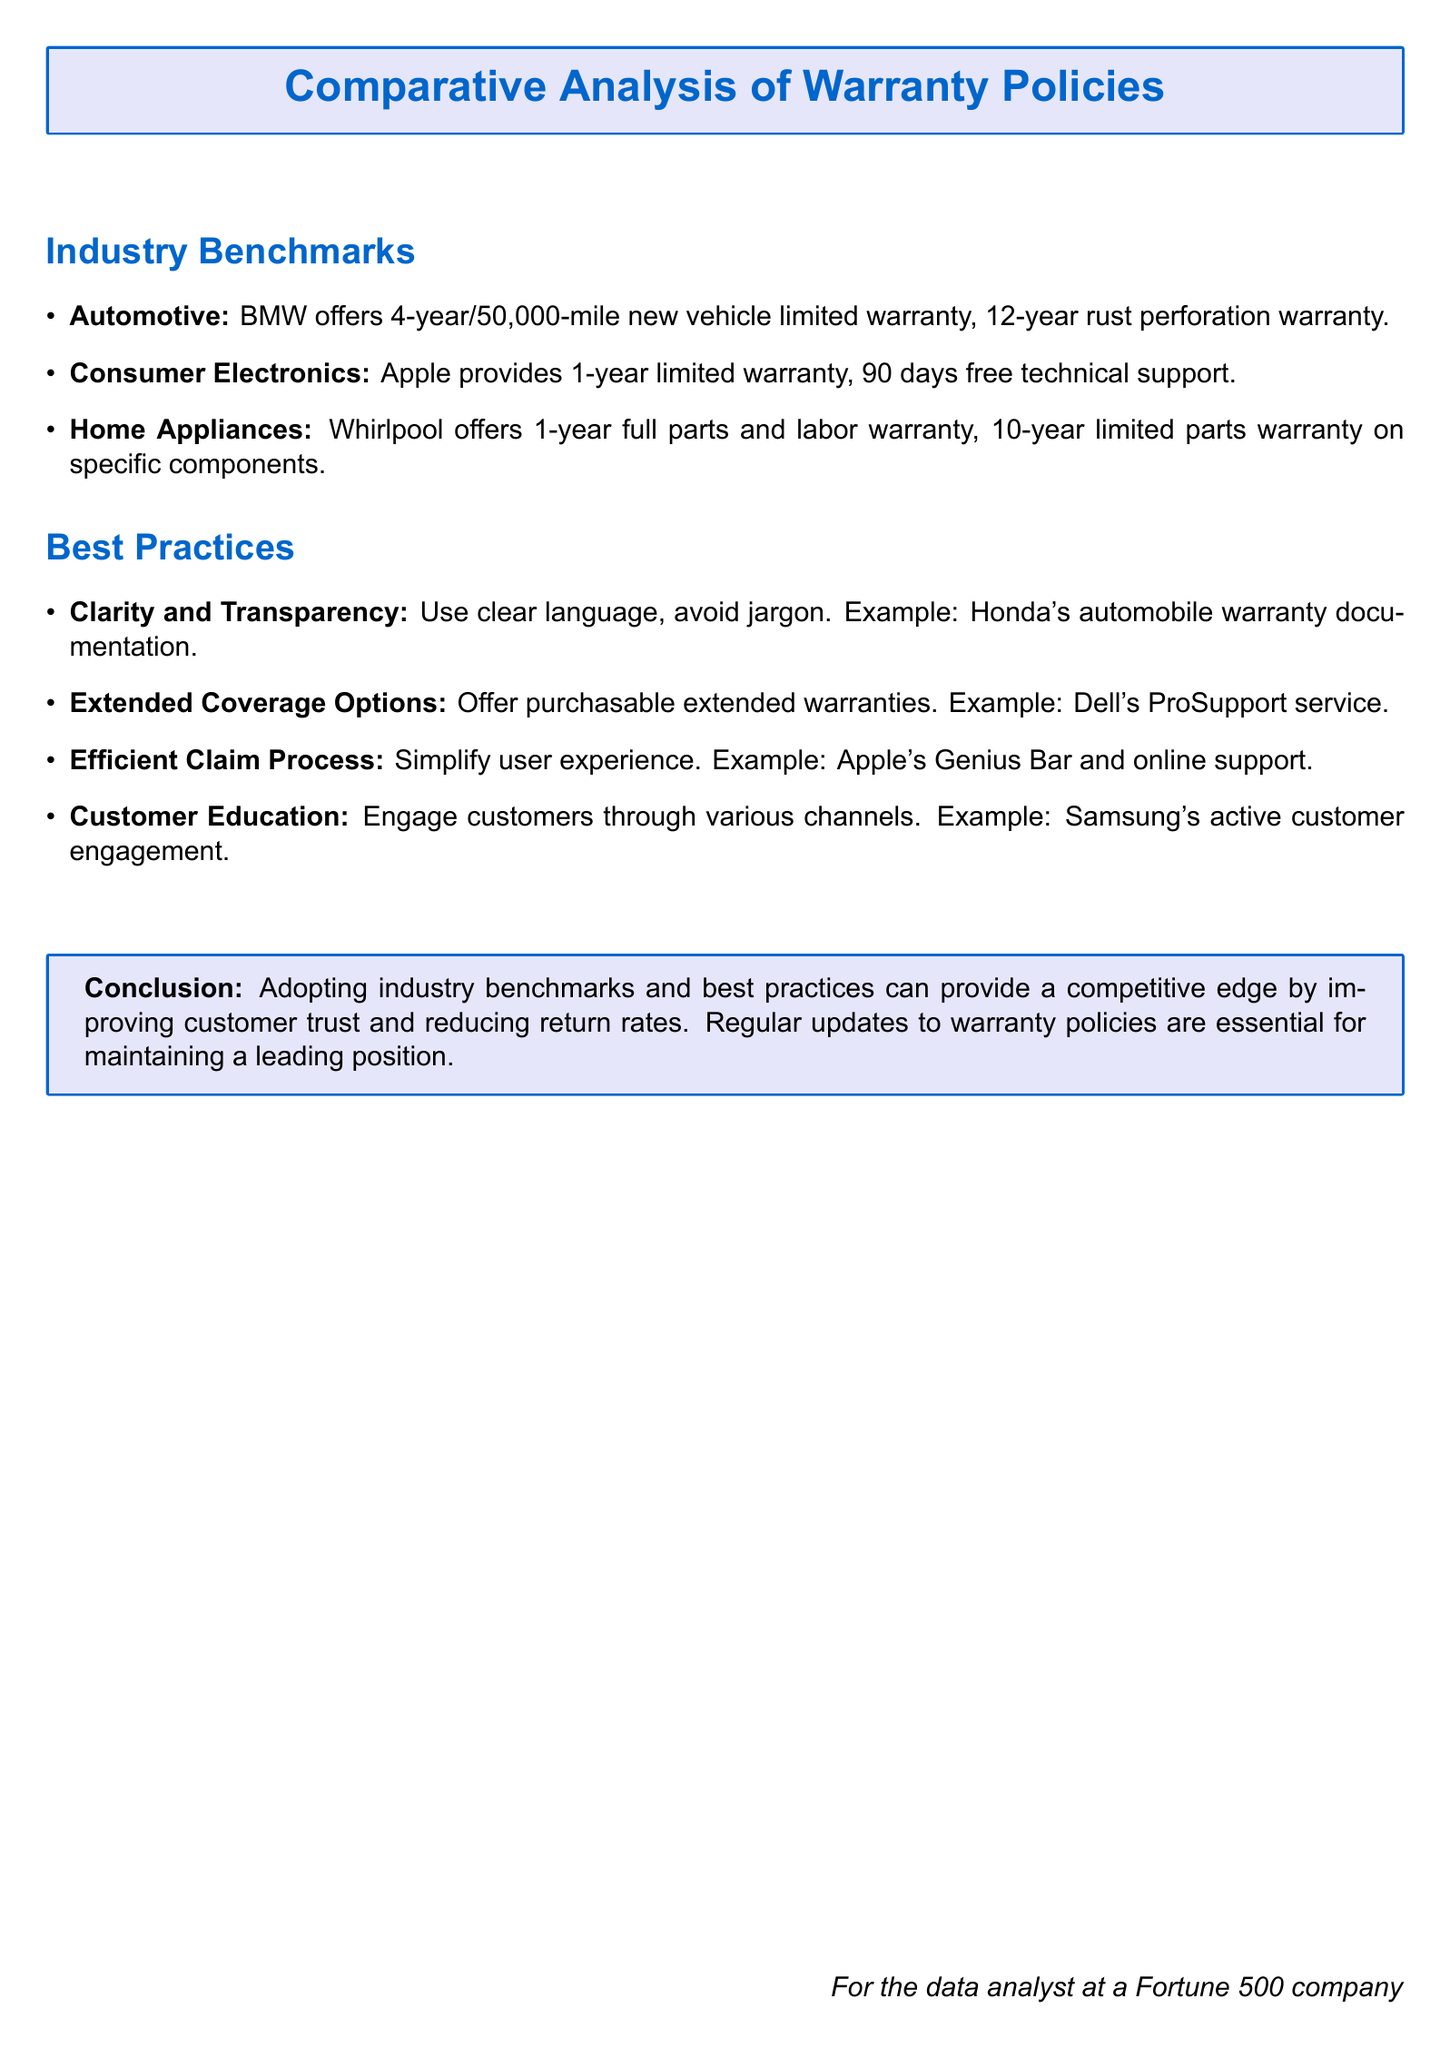What is the warranty period for BMW vehicles? The document states that BMW offers a 4-year/50,000-mile new vehicle limited warranty.
Answer: 4-year/50,000-mile What type of warranty does Apple provide? The document mentions that Apple provides a 1-year limited warranty.
Answer: 1-year limited warranty How long is the rust perforation warranty for BMW? The rust perforation warranty for BMW is stated as 12 years.
Answer: 12-year What is a best practice related to claim processes? The document highlights simplifying the user experience as a best practice for claims.
Answer: Simplify user experience Which company's warranty documentation is cited as clear and transparent? The document gives an example of Honda's automobile warranty documentation for clarity.
Answer: Honda What does Samsung actively engage in according to best practices? The document mentions that Samsung engages customers through various channels.
Answer: Customer engagement How long is Whirlpool's full parts and labor warranty? According to the document, Whirlpool offers a 1-year full parts and labor warranty.
Answer: 1-year What is the purpose of adopting industry benchmarks in warranty policies? The document states that adopting industry benchmarks can improve customer trust and reduce return rates.
Answer: Improve customer trust What is one of the warranty options provided by Dell? The document describes Dell's ProSupport service as an extended warranty option.
Answer: ProSupport service What is a recommendation mentioned for customer education? The document advises engaging customers through various channels for education.
Answer: Engage customers through various channels 